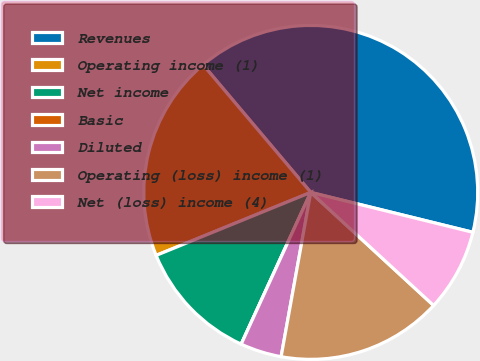<chart> <loc_0><loc_0><loc_500><loc_500><pie_chart><fcel>Revenues<fcel>Operating income (1)<fcel>Net income<fcel>Basic<fcel>Diluted<fcel>Operating (loss) income (1)<fcel>Net (loss) income (4)<nl><fcel>40.0%<fcel>20.0%<fcel>12.0%<fcel>0.0%<fcel>4.0%<fcel>16.0%<fcel>8.0%<nl></chart> 